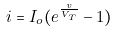<formula> <loc_0><loc_0><loc_500><loc_500>i = I _ { o } ( e ^ { \frac { v } { V _ { T } } } - 1 )</formula> 